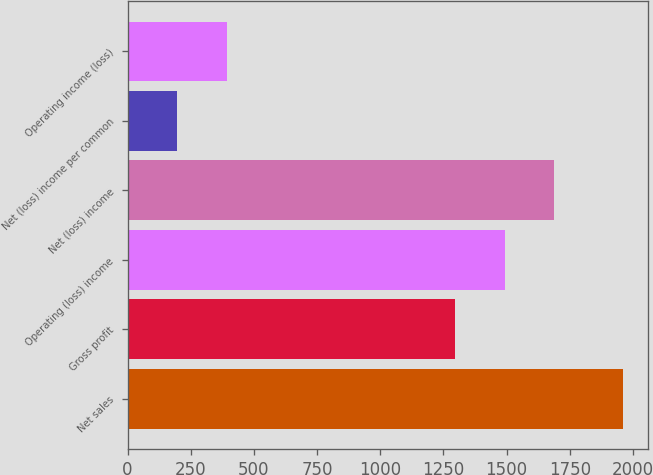<chart> <loc_0><loc_0><loc_500><loc_500><bar_chart><fcel>Net sales<fcel>Gross profit<fcel>Operating (loss) income<fcel>Net (loss) income<fcel>Net (loss) income per common<fcel>Operating income (loss)<nl><fcel>1960<fcel>1297<fcel>1492.89<fcel>1688.79<fcel>196.95<fcel>392.85<nl></chart> 